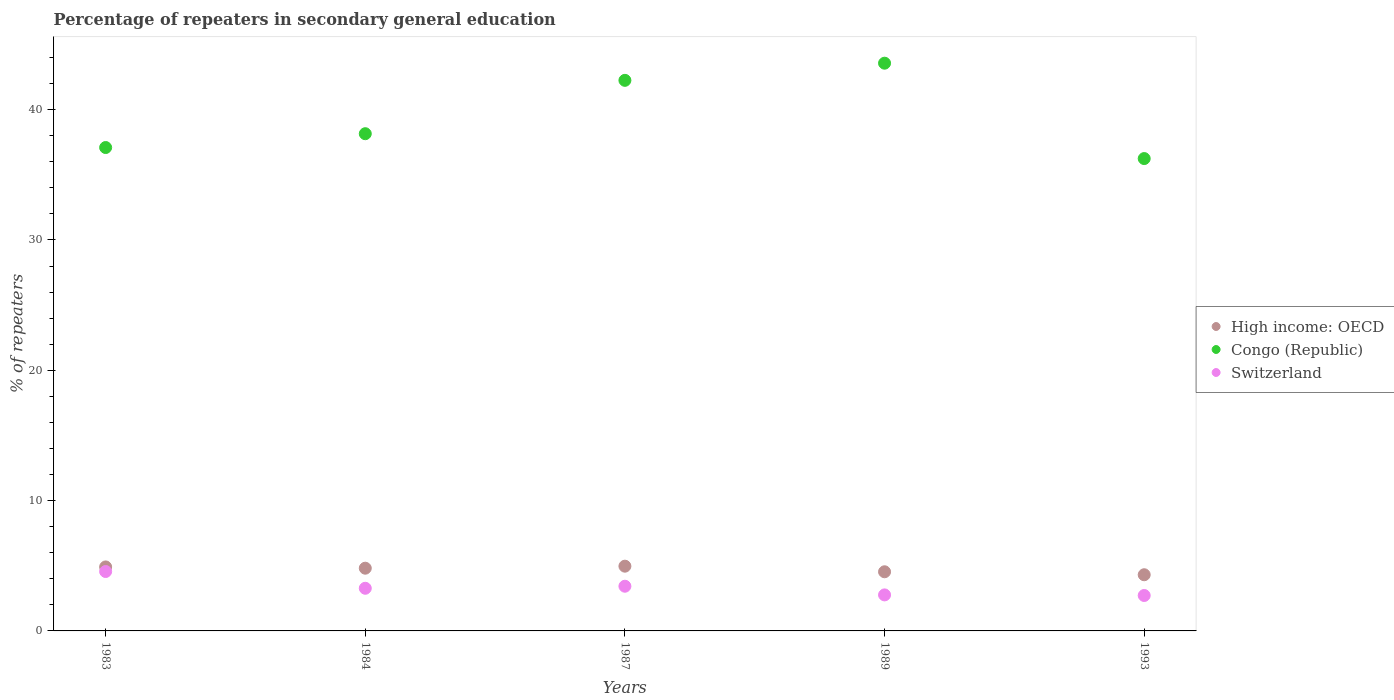How many different coloured dotlines are there?
Give a very brief answer. 3. Is the number of dotlines equal to the number of legend labels?
Provide a succinct answer. Yes. What is the percentage of repeaters in secondary general education in Congo (Republic) in 1989?
Provide a succinct answer. 43.56. Across all years, what is the maximum percentage of repeaters in secondary general education in High income: OECD?
Your answer should be very brief. 4.97. Across all years, what is the minimum percentage of repeaters in secondary general education in Switzerland?
Your answer should be very brief. 2.72. In which year was the percentage of repeaters in secondary general education in High income: OECD minimum?
Provide a succinct answer. 1993. What is the total percentage of repeaters in secondary general education in Switzerland in the graph?
Provide a short and direct response. 16.74. What is the difference between the percentage of repeaters in secondary general education in High income: OECD in 1987 and that in 1993?
Your answer should be very brief. 0.66. What is the difference between the percentage of repeaters in secondary general education in Congo (Republic) in 1989 and the percentage of repeaters in secondary general education in Switzerland in 1987?
Your response must be concise. 40.13. What is the average percentage of repeaters in secondary general education in Switzerland per year?
Provide a succinct answer. 3.35. In the year 1983, what is the difference between the percentage of repeaters in secondary general education in Switzerland and percentage of repeaters in secondary general education in Congo (Republic)?
Provide a succinct answer. -32.53. In how many years, is the percentage of repeaters in secondary general education in Switzerland greater than 40 %?
Keep it short and to the point. 0. What is the ratio of the percentage of repeaters in secondary general education in Switzerland in 1984 to that in 1989?
Keep it short and to the point. 1.18. Is the percentage of repeaters in secondary general education in Switzerland in 1984 less than that in 1987?
Make the answer very short. Yes. Is the difference between the percentage of repeaters in secondary general education in Switzerland in 1984 and 1989 greater than the difference between the percentage of repeaters in secondary general education in Congo (Republic) in 1984 and 1989?
Ensure brevity in your answer.  Yes. What is the difference between the highest and the second highest percentage of repeaters in secondary general education in Switzerland?
Ensure brevity in your answer.  1.13. What is the difference between the highest and the lowest percentage of repeaters in secondary general education in Switzerland?
Provide a succinct answer. 1.84. How many legend labels are there?
Give a very brief answer. 3. How are the legend labels stacked?
Your answer should be compact. Vertical. What is the title of the graph?
Offer a terse response. Percentage of repeaters in secondary general education. Does "Kenya" appear as one of the legend labels in the graph?
Make the answer very short. No. What is the label or title of the Y-axis?
Make the answer very short. % of repeaters. What is the % of repeaters of High income: OECD in 1983?
Offer a very short reply. 4.91. What is the % of repeaters of Congo (Republic) in 1983?
Offer a terse response. 37.09. What is the % of repeaters of Switzerland in 1983?
Keep it short and to the point. 4.56. What is the % of repeaters of High income: OECD in 1984?
Give a very brief answer. 4.81. What is the % of repeaters of Congo (Republic) in 1984?
Ensure brevity in your answer.  38.15. What is the % of repeaters in Switzerland in 1984?
Your response must be concise. 3.27. What is the % of repeaters of High income: OECD in 1987?
Your answer should be compact. 4.97. What is the % of repeaters in Congo (Republic) in 1987?
Your answer should be very brief. 42.25. What is the % of repeaters of Switzerland in 1987?
Your response must be concise. 3.43. What is the % of repeaters in High income: OECD in 1989?
Provide a short and direct response. 4.54. What is the % of repeaters in Congo (Republic) in 1989?
Your response must be concise. 43.56. What is the % of repeaters of Switzerland in 1989?
Ensure brevity in your answer.  2.76. What is the % of repeaters in High income: OECD in 1993?
Provide a succinct answer. 4.31. What is the % of repeaters in Congo (Republic) in 1993?
Offer a very short reply. 36.24. What is the % of repeaters in Switzerland in 1993?
Your answer should be very brief. 2.72. Across all years, what is the maximum % of repeaters of High income: OECD?
Offer a very short reply. 4.97. Across all years, what is the maximum % of repeaters of Congo (Republic)?
Provide a succinct answer. 43.56. Across all years, what is the maximum % of repeaters in Switzerland?
Provide a short and direct response. 4.56. Across all years, what is the minimum % of repeaters of High income: OECD?
Your answer should be compact. 4.31. Across all years, what is the minimum % of repeaters in Congo (Republic)?
Provide a succinct answer. 36.24. Across all years, what is the minimum % of repeaters of Switzerland?
Give a very brief answer. 2.72. What is the total % of repeaters in High income: OECD in the graph?
Provide a succinct answer. 23.54. What is the total % of repeaters of Congo (Republic) in the graph?
Offer a very short reply. 197.29. What is the total % of repeaters of Switzerland in the graph?
Your response must be concise. 16.74. What is the difference between the % of repeaters of High income: OECD in 1983 and that in 1984?
Ensure brevity in your answer.  0.1. What is the difference between the % of repeaters of Congo (Republic) in 1983 and that in 1984?
Keep it short and to the point. -1.06. What is the difference between the % of repeaters of Switzerland in 1983 and that in 1984?
Provide a short and direct response. 1.29. What is the difference between the % of repeaters in High income: OECD in 1983 and that in 1987?
Offer a terse response. -0.06. What is the difference between the % of repeaters of Congo (Republic) in 1983 and that in 1987?
Provide a succinct answer. -5.16. What is the difference between the % of repeaters in Switzerland in 1983 and that in 1987?
Offer a very short reply. 1.13. What is the difference between the % of repeaters in High income: OECD in 1983 and that in 1989?
Ensure brevity in your answer.  0.37. What is the difference between the % of repeaters in Congo (Republic) in 1983 and that in 1989?
Give a very brief answer. -6.47. What is the difference between the % of repeaters in Switzerland in 1983 and that in 1989?
Make the answer very short. 1.79. What is the difference between the % of repeaters in High income: OECD in 1983 and that in 1993?
Give a very brief answer. 0.6. What is the difference between the % of repeaters of Congo (Republic) in 1983 and that in 1993?
Ensure brevity in your answer.  0.85. What is the difference between the % of repeaters of Switzerland in 1983 and that in 1993?
Your response must be concise. 1.84. What is the difference between the % of repeaters in High income: OECD in 1984 and that in 1987?
Offer a very short reply. -0.16. What is the difference between the % of repeaters of Congo (Republic) in 1984 and that in 1987?
Your answer should be very brief. -4.09. What is the difference between the % of repeaters of Switzerland in 1984 and that in 1987?
Provide a succinct answer. -0.16. What is the difference between the % of repeaters in High income: OECD in 1984 and that in 1989?
Keep it short and to the point. 0.27. What is the difference between the % of repeaters of Congo (Republic) in 1984 and that in 1989?
Give a very brief answer. -5.41. What is the difference between the % of repeaters of Switzerland in 1984 and that in 1989?
Your response must be concise. 0.51. What is the difference between the % of repeaters in High income: OECD in 1984 and that in 1993?
Offer a terse response. 0.5. What is the difference between the % of repeaters of Congo (Republic) in 1984 and that in 1993?
Give a very brief answer. 1.91. What is the difference between the % of repeaters of Switzerland in 1984 and that in 1993?
Your answer should be compact. 0.55. What is the difference between the % of repeaters in High income: OECD in 1987 and that in 1989?
Your answer should be very brief. 0.43. What is the difference between the % of repeaters in Congo (Republic) in 1987 and that in 1989?
Offer a terse response. -1.32. What is the difference between the % of repeaters in Switzerland in 1987 and that in 1989?
Offer a very short reply. 0.67. What is the difference between the % of repeaters in High income: OECD in 1987 and that in 1993?
Offer a very short reply. 0.66. What is the difference between the % of repeaters in Congo (Republic) in 1987 and that in 1993?
Offer a terse response. 6. What is the difference between the % of repeaters in Switzerland in 1987 and that in 1993?
Provide a short and direct response. 0.71. What is the difference between the % of repeaters in High income: OECD in 1989 and that in 1993?
Provide a short and direct response. 0.23. What is the difference between the % of repeaters in Congo (Republic) in 1989 and that in 1993?
Offer a very short reply. 7.32. What is the difference between the % of repeaters of Switzerland in 1989 and that in 1993?
Your answer should be very brief. 0.04. What is the difference between the % of repeaters of High income: OECD in 1983 and the % of repeaters of Congo (Republic) in 1984?
Offer a very short reply. -33.24. What is the difference between the % of repeaters in High income: OECD in 1983 and the % of repeaters in Switzerland in 1984?
Provide a succinct answer. 1.64. What is the difference between the % of repeaters of Congo (Republic) in 1983 and the % of repeaters of Switzerland in 1984?
Your answer should be compact. 33.82. What is the difference between the % of repeaters of High income: OECD in 1983 and the % of repeaters of Congo (Republic) in 1987?
Provide a succinct answer. -37.34. What is the difference between the % of repeaters of High income: OECD in 1983 and the % of repeaters of Switzerland in 1987?
Provide a short and direct response. 1.48. What is the difference between the % of repeaters of Congo (Republic) in 1983 and the % of repeaters of Switzerland in 1987?
Give a very brief answer. 33.66. What is the difference between the % of repeaters in High income: OECD in 1983 and the % of repeaters in Congo (Republic) in 1989?
Offer a very short reply. -38.65. What is the difference between the % of repeaters in High income: OECD in 1983 and the % of repeaters in Switzerland in 1989?
Make the answer very short. 2.15. What is the difference between the % of repeaters of Congo (Republic) in 1983 and the % of repeaters of Switzerland in 1989?
Offer a very short reply. 34.33. What is the difference between the % of repeaters in High income: OECD in 1983 and the % of repeaters in Congo (Republic) in 1993?
Give a very brief answer. -31.33. What is the difference between the % of repeaters of High income: OECD in 1983 and the % of repeaters of Switzerland in 1993?
Your answer should be very brief. 2.19. What is the difference between the % of repeaters of Congo (Republic) in 1983 and the % of repeaters of Switzerland in 1993?
Make the answer very short. 34.37. What is the difference between the % of repeaters of High income: OECD in 1984 and the % of repeaters of Congo (Republic) in 1987?
Keep it short and to the point. -37.43. What is the difference between the % of repeaters in High income: OECD in 1984 and the % of repeaters in Switzerland in 1987?
Your answer should be compact. 1.38. What is the difference between the % of repeaters in Congo (Republic) in 1984 and the % of repeaters in Switzerland in 1987?
Offer a very short reply. 34.72. What is the difference between the % of repeaters in High income: OECD in 1984 and the % of repeaters in Congo (Republic) in 1989?
Your answer should be very brief. -38.75. What is the difference between the % of repeaters in High income: OECD in 1984 and the % of repeaters in Switzerland in 1989?
Your answer should be very brief. 2.05. What is the difference between the % of repeaters of Congo (Republic) in 1984 and the % of repeaters of Switzerland in 1989?
Make the answer very short. 35.39. What is the difference between the % of repeaters of High income: OECD in 1984 and the % of repeaters of Congo (Republic) in 1993?
Provide a succinct answer. -31.43. What is the difference between the % of repeaters of High income: OECD in 1984 and the % of repeaters of Switzerland in 1993?
Ensure brevity in your answer.  2.09. What is the difference between the % of repeaters of Congo (Republic) in 1984 and the % of repeaters of Switzerland in 1993?
Offer a very short reply. 35.43. What is the difference between the % of repeaters of High income: OECD in 1987 and the % of repeaters of Congo (Republic) in 1989?
Make the answer very short. -38.59. What is the difference between the % of repeaters of High income: OECD in 1987 and the % of repeaters of Switzerland in 1989?
Offer a very short reply. 2.2. What is the difference between the % of repeaters in Congo (Republic) in 1987 and the % of repeaters in Switzerland in 1989?
Keep it short and to the point. 39.48. What is the difference between the % of repeaters of High income: OECD in 1987 and the % of repeaters of Congo (Republic) in 1993?
Your answer should be compact. -31.28. What is the difference between the % of repeaters in High income: OECD in 1987 and the % of repeaters in Switzerland in 1993?
Offer a terse response. 2.25. What is the difference between the % of repeaters in Congo (Republic) in 1987 and the % of repeaters in Switzerland in 1993?
Provide a succinct answer. 39.53. What is the difference between the % of repeaters in High income: OECD in 1989 and the % of repeaters in Congo (Republic) in 1993?
Make the answer very short. -31.71. What is the difference between the % of repeaters of High income: OECD in 1989 and the % of repeaters of Switzerland in 1993?
Your response must be concise. 1.82. What is the difference between the % of repeaters in Congo (Republic) in 1989 and the % of repeaters in Switzerland in 1993?
Give a very brief answer. 40.84. What is the average % of repeaters of High income: OECD per year?
Your answer should be very brief. 4.71. What is the average % of repeaters of Congo (Republic) per year?
Ensure brevity in your answer.  39.46. What is the average % of repeaters in Switzerland per year?
Your answer should be very brief. 3.35. In the year 1983, what is the difference between the % of repeaters in High income: OECD and % of repeaters in Congo (Republic)?
Give a very brief answer. -32.18. In the year 1983, what is the difference between the % of repeaters in High income: OECD and % of repeaters in Switzerland?
Offer a very short reply. 0.35. In the year 1983, what is the difference between the % of repeaters of Congo (Republic) and % of repeaters of Switzerland?
Ensure brevity in your answer.  32.53. In the year 1984, what is the difference between the % of repeaters in High income: OECD and % of repeaters in Congo (Republic)?
Your answer should be very brief. -33.34. In the year 1984, what is the difference between the % of repeaters of High income: OECD and % of repeaters of Switzerland?
Make the answer very short. 1.54. In the year 1984, what is the difference between the % of repeaters in Congo (Republic) and % of repeaters in Switzerland?
Keep it short and to the point. 34.88. In the year 1987, what is the difference between the % of repeaters in High income: OECD and % of repeaters in Congo (Republic)?
Provide a succinct answer. -37.28. In the year 1987, what is the difference between the % of repeaters of High income: OECD and % of repeaters of Switzerland?
Your answer should be compact. 1.54. In the year 1987, what is the difference between the % of repeaters in Congo (Republic) and % of repeaters in Switzerland?
Your answer should be very brief. 38.82. In the year 1989, what is the difference between the % of repeaters in High income: OECD and % of repeaters in Congo (Republic)?
Ensure brevity in your answer.  -39.02. In the year 1989, what is the difference between the % of repeaters of High income: OECD and % of repeaters of Switzerland?
Your answer should be very brief. 1.77. In the year 1989, what is the difference between the % of repeaters of Congo (Republic) and % of repeaters of Switzerland?
Give a very brief answer. 40.8. In the year 1993, what is the difference between the % of repeaters in High income: OECD and % of repeaters in Congo (Republic)?
Offer a very short reply. -31.93. In the year 1993, what is the difference between the % of repeaters of High income: OECD and % of repeaters of Switzerland?
Your response must be concise. 1.59. In the year 1993, what is the difference between the % of repeaters in Congo (Republic) and % of repeaters in Switzerland?
Provide a short and direct response. 33.53. What is the ratio of the % of repeaters in High income: OECD in 1983 to that in 1984?
Your answer should be very brief. 1.02. What is the ratio of the % of repeaters in Congo (Republic) in 1983 to that in 1984?
Give a very brief answer. 0.97. What is the ratio of the % of repeaters of Switzerland in 1983 to that in 1984?
Your answer should be compact. 1.39. What is the ratio of the % of repeaters of High income: OECD in 1983 to that in 1987?
Ensure brevity in your answer.  0.99. What is the ratio of the % of repeaters of Congo (Republic) in 1983 to that in 1987?
Make the answer very short. 0.88. What is the ratio of the % of repeaters in Switzerland in 1983 to that in 1987?
Provide a short and direct response. 1.33. What is the ratio of the % of repeaters in High income: OECD in 1983 to that in 1989?
Make the answer very short. 1.08. What is the ratio of the % of repeaters of Congo (Republic) in 1983 to that in 1989?
Make the answer very short. 0.85. What is the ratio of the % of repeaters in Switzerland in 1983 to that in 1989?
Provide a short and direct response. 1.65. What is the ratio of the % of repeaters of High income: OECD in 1983 to that in 1993?
Give a very brief answer. 1.14. What is the ratio of the % of repeaters in Congo (Republic) in 1983 to that in 1993?
Make the answer very short. 1.02. What is the ratio of the % of repeaters in Switzerland in 1983 to that in 1993?
Provide a succinct answer. 1.68. What is the ratio of the % of repeaters in High income: OECD in 1984 to that in 1987?
Offer a terse response. 0.97. What is the ratio of the % of repeaters in Congo (Republic) in 1984 to that in 1987?
Make the answer very short. 0.9. What is the ratio of the % of repeaters of Switzerland in 1984 to that in 1987?
Provide a short and direct response. 0.95. What is the ratio of the % of repeaters in High income: OECD in 1984 to that in 1989?
Ensure brevity in your answer.  1.06. What is the ratio of the % of repeaters in Congo (Republic) in 1984 to that in 1989?
Your answer should be very brief. 0.88. What is the ratio of the % of repeaters of Switzerland in 1984 to that in 1989?
Provide a succinct answer. 1.18. What is the ratio of the % of repeaters of High income: OECD in 1984 to that in 1993?
Provide a short and direct response. 1.12. What is the ratio of the % of repeaters in Congo (Republic) in 1984 to that in 1993?
Keep it short and to the point. 1.05. What is the ratio of the % of repeaters in Switzerland in 1984 to that in 1993?
Keep it short and to the point. 1.2. What is the ratio of the % of repeaters in High income: OECD in 1987 to that in 1989?
Your answer should be very brief. 1.09. What is the ratio of the % of repeaters of Congo (Republic) in 1987 to that in 1989?
Make the answer very short. 0.97. What is the ratio of the % of repeaters in Switzerland in 1987 to that in 1989?
Provide a succinct answer. 1.24. What is the ratio of the % of repeaters of High income: OECD in 1987 to that in 1993?
Give a very brief answer. 1.15. What is the ratio of the % of repeaters in Congo (Republic) in 1987 to that in 1993?
Your response must be concise. 1.17. What is the ratio of the % of repeaters of Switzerland in 1987 to that in 1993?
Provide a short and direct response. 1.26. What is the ratio of the % of repeaters of High income: OECD in 1989 to that in 1993?
Offer a terse response. 1.05. What is the ratio of the % of repeaters in Congo (Republic) in 1989 to that in 1993?
Your response must be concise. 1.2. What is the ratio of the % of repeaters of Switzerland in 1989 to that in 1993?
Provide a short and direct response. 1.02. What is the difference between the highest and the second highest % of repeaters in High income: OECD?
Offer a very short reply. 0.06. What is the difference between the highest and the second highest % of repeaters in Congo (Republic)?
Keep it short and to the point. 1.32. What is the difference between the highest and the second highest % of repeaters of Switzerland?
Make the answer very short. 1.13. What is the difference between the highest and the lowest % of repeaters of High income: OECD?
Keep it short and to the point. 0.66. What is the difference between the highest and the lowest % of repeaters of Congo (Republic)?
Offer a very short reply. 7.32. What is the difference between the highest and the lowest % of repeaters of Switzerland?
Provide a short and direct response. 1.84. 